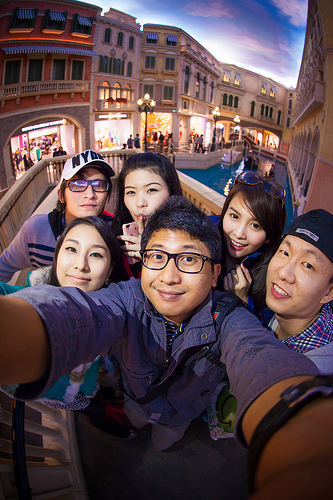<image>
Is there a man to the right of the woman? No. The man is not to the right of the woman. The horizontal positioning shows a different relationship. 